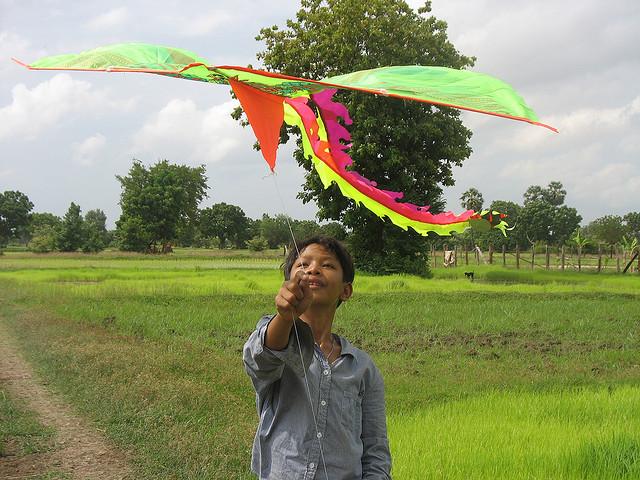Do you see a dog in this photo?
Keep it brief. No. Who is in the photo?
Keep it brief. Boy. What is the boy playing with?
Write a very short answer. Kite. What color is his shirt?
Short answer required. Gray. 